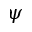<formula> <loc_0><loc_0><loc_500><loc_500>\psi</formula> 